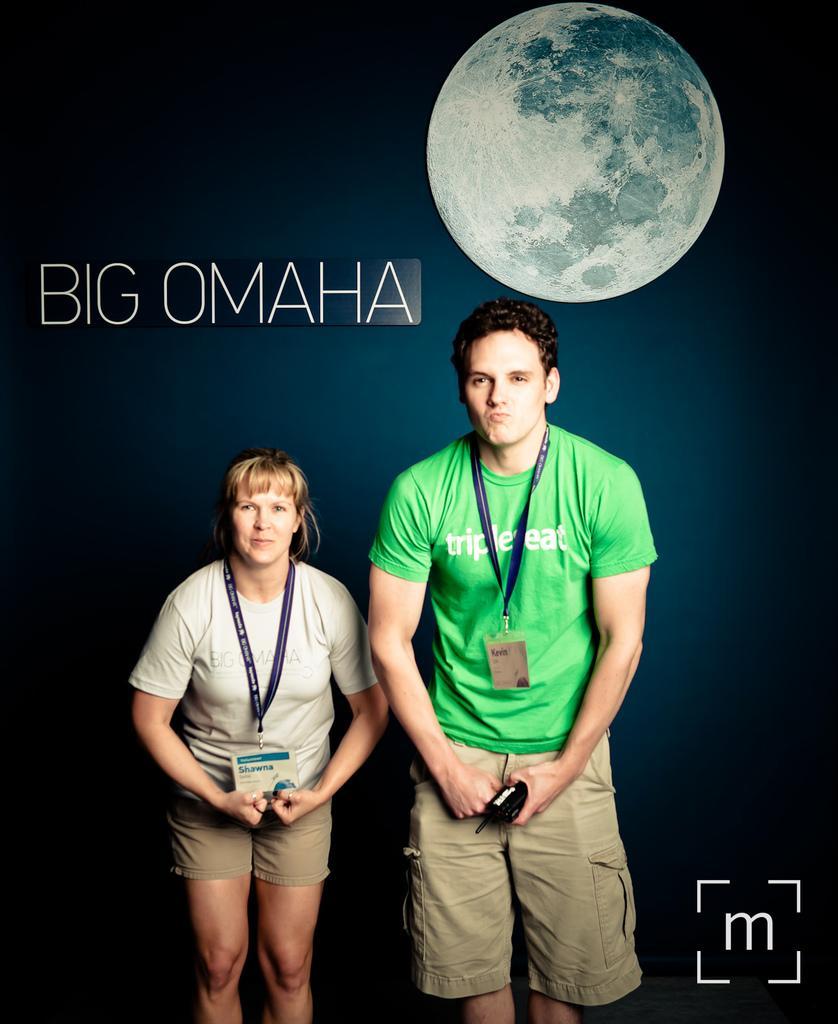How would you summarize this image in a sentence or two? In this picture there are two persons standing and holding the object. At the back there is a picture of a moon and there is a text. At the bottom right there is a logo. 